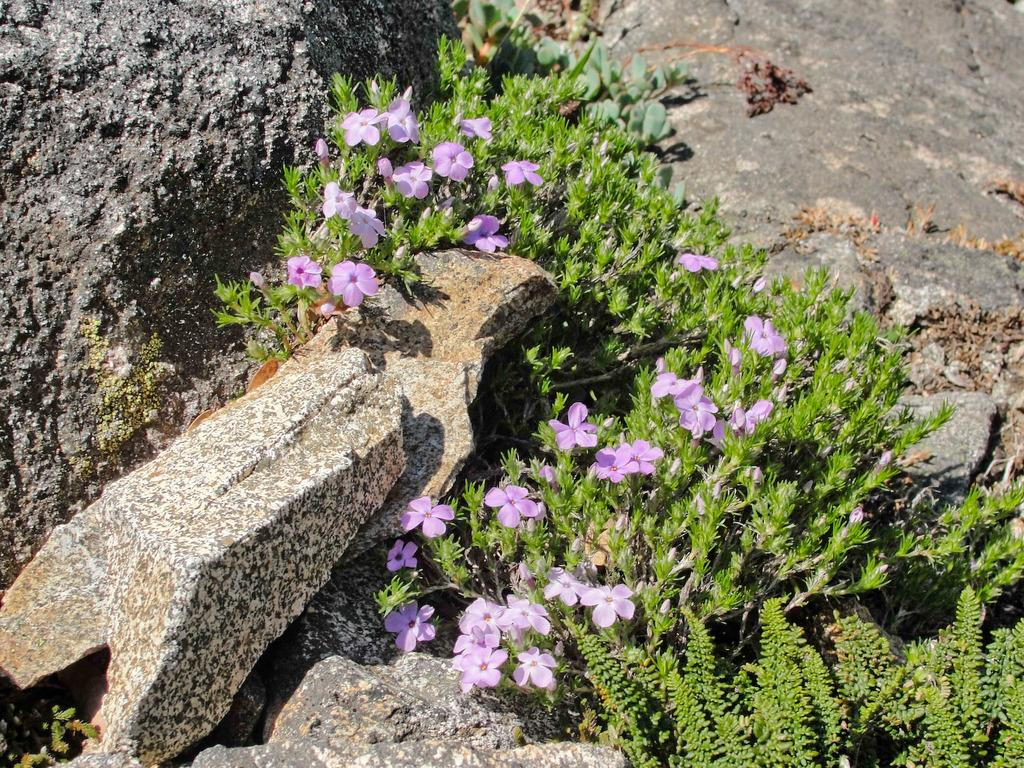What type of living organisms are present in the image? There are plants in the image. What specific features can be observed on the plants? The plants have flowers and leaves. Can you describe the object on the left side of the image? There is a rock on the left side on the left side of the image. Where is the brother in the image? There is no brother present in the image. How many bikes are visible in the image? There are no bikes present in the image. 